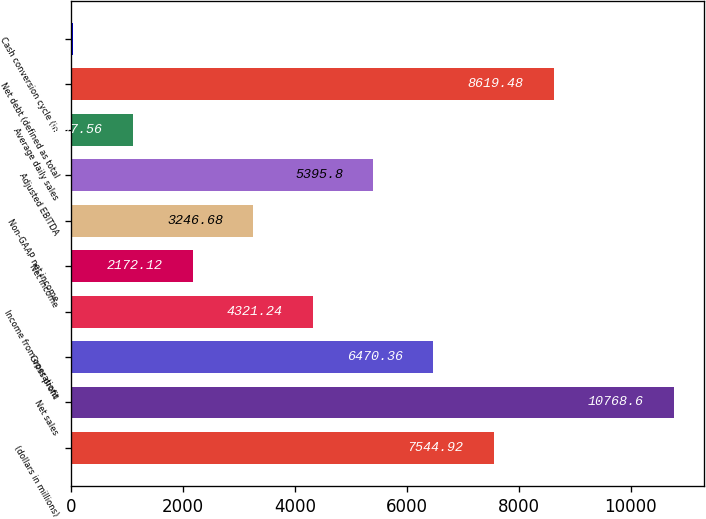Convert chart. <chart><loc_0><loc_0><loc_500><loc_500><bar_chart><fcel>(dollars in millions)<fcel>Net sales<fcel>Gross profit<fcel>Income from operations<fcel>Net income<fcel>Non-GAAP net income<fcel>Adjusted EBITDA<fcel>Average daily sales<fcel>Net debt (defined as total<fcel>Cash conversion cycle (in<nl><fcel>7544.92<fcel>10768.6<fcel>6470.36<fcel>4321.24<fcel>2172.12<fcel>3246.68<fcel>5395.8<fcel>1097.56<fcel>8619.48<fcel>23<nl></chart> 